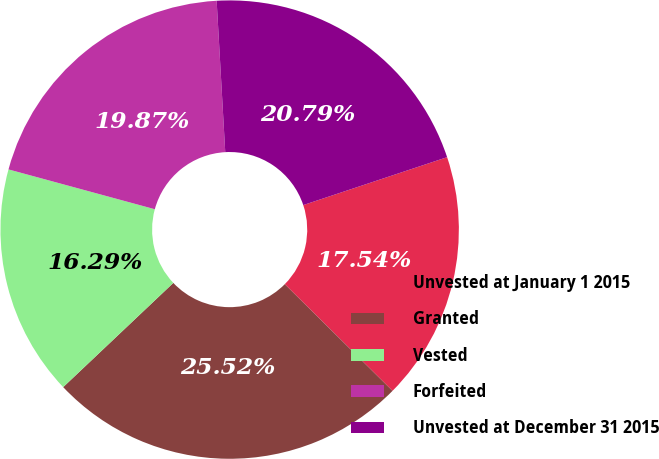Convert chart. <chart><loc_0><loc_0><loc_500><loc_500><pie_chart><fcel>Unvested at January 1 2015<fcel>Granted<fcel>Vested<fcel>Forfeited<fcel>Unvested at December 31 2015<nl><fcel>17.54%<fcel>25.52%<fcel>16.29%<fcel>19.87%<fcel>20.79%<nl></chart> 